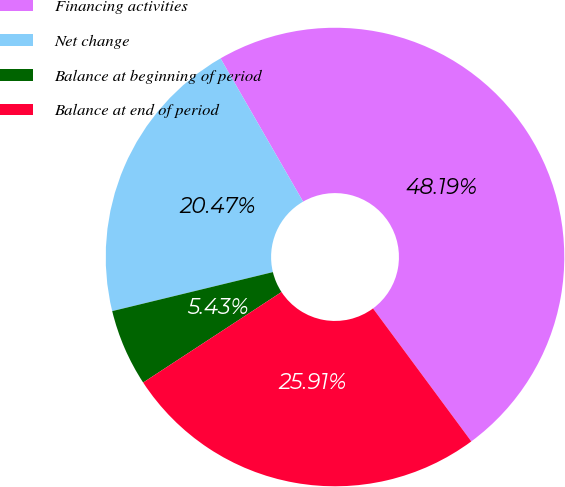Convert chart. <chart><loc_0><loc_0><loc_500><loc_500><pie_chart><fcel>Financing activities<fcel>Net change<fcel>Balance at beginning of period<fcel>Balance at end of period<nl><fcel>48.19%<fcel>20.47%<fcel>5.43%<fcel>25.91%<nl></chart> 